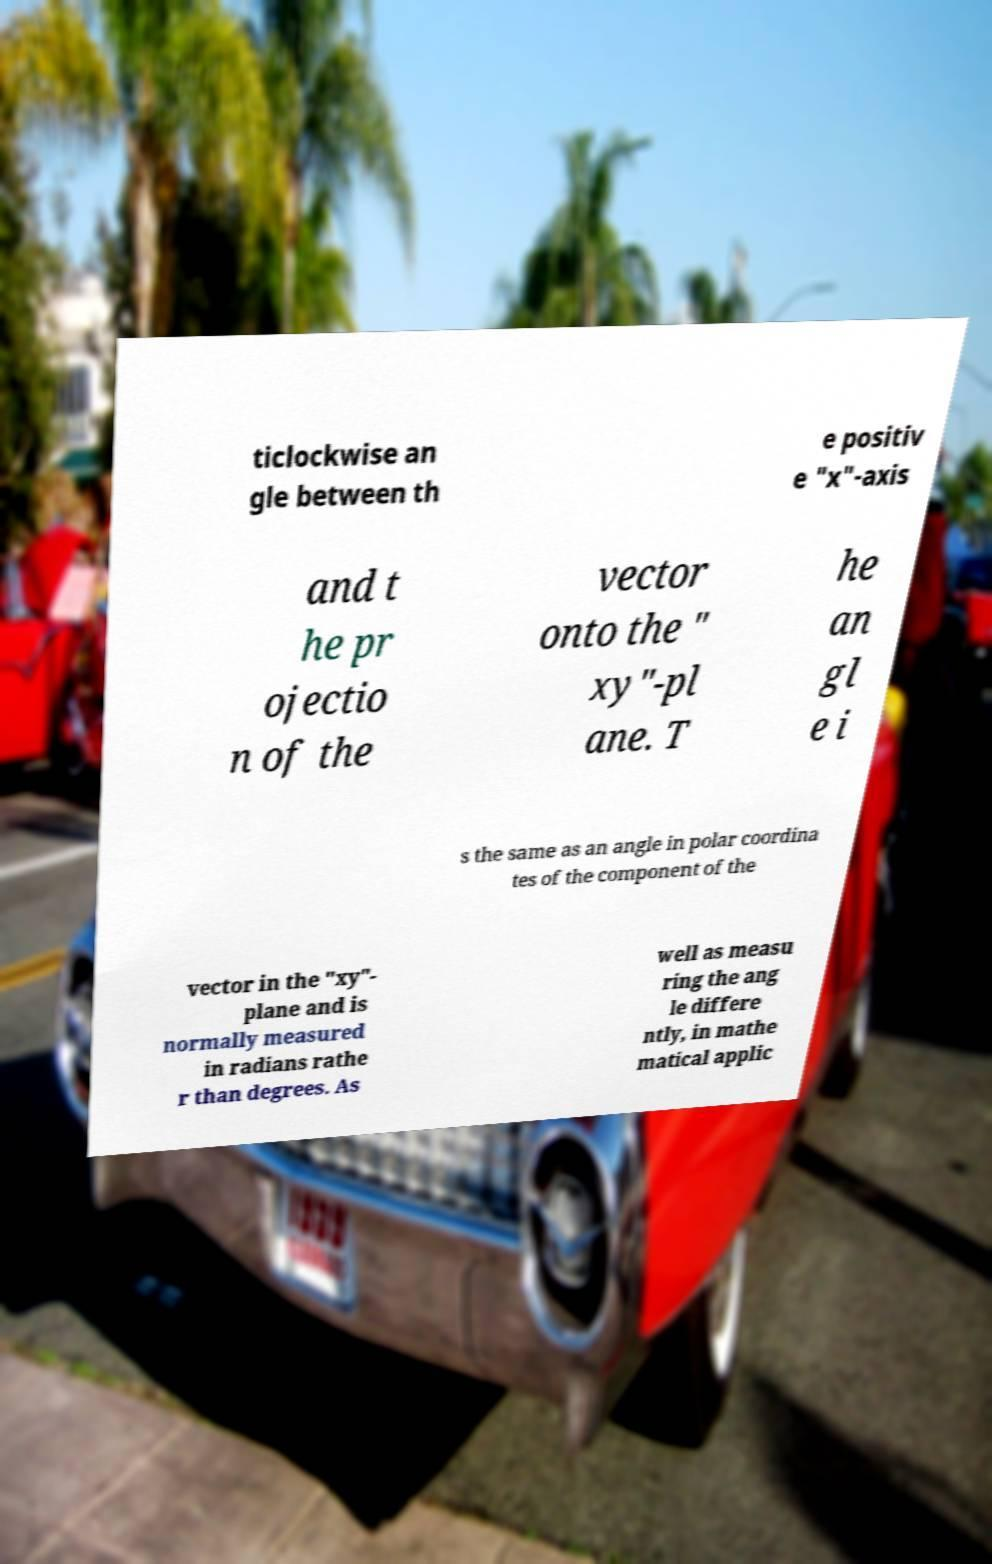There's text embedded in this image that I need extracted. Can you transcribe it verbatim? ticlockwise an gle between th e positiv e "x"-axis and t he pr ojectio n of the vector onto the " xy"-pl ane. T he an gl e i s the same as an angle in polar coordina tes of the component of the vector in the "xy"- plane and is normally measured in radians rathe r than degrees. As well as measu ring the ang le differe ntly, in mathe matical applic 